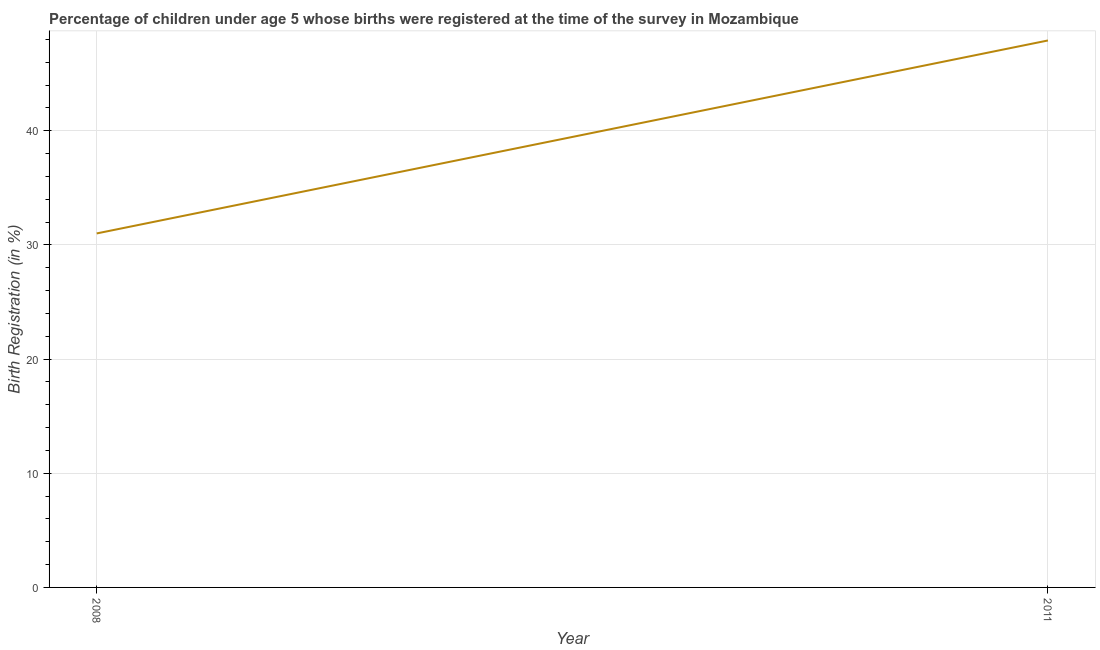What is the birth registration in 2011?
Keep it short and to the point. 47.9. Across all years, what is the maximum birth registration?
Your answer should be very brief. 47.9. In which year was the birth registration minimum?
Provide a short and direct response. 2008. What is the sum of the birth registration?
Keep it short and to the point. 78.9. What is the difference between the birth registration in 2008 and 2011?
Give a very brief answer. -16.9. What is the average birth registration per year?
Provide a short and direct response. 39.45. What is the median birth registration?
Offer a terse response. 39.45. In how many years, is the birth registration greater than 28 %?
Offer a very short reply. 2. What is the ratio of the birth registration in 2008 to that in 2011?
Offer a terse response. 0.65. Is the birth registration in 2008 less than that in 2011?
Your answer should be compact. Yes. Does the birth registration monotonically increase over the years?
Offer a very short reply. Yes. How many lines are there?
Offer a terse response. 1. How many years are there in the graph?
Your response must be concise. 2. What is the difference between two consecutive major ticks on the Y-axis?
Keep it short and to the point. 10. Are the values on the major ticks of Y-axis written in scientific E-notation?
Make the answer very short. No. What is the title of the graph?
Provide a succinct answer. Percentage of children under age 5 whose births were registered at the time of the survey in Mozambique. What is the label or title of the X-axis?
Ensure brevity in your answer.  Year. What is the label or title of the Y-axis?
Ensure brevity in your answer.  Birth Registration (in %). What is the Birth Registration (in %) in 2011?
Make the answer very short. 47.9. What is the difference between the Birth Registration (in %) in 2008 and 2011?
Your response must be concise. -16.9. What is the ratio of the Birth Registration (in %) in 2008 to that in 2011?
Your answer should be very brief. 0.65. 